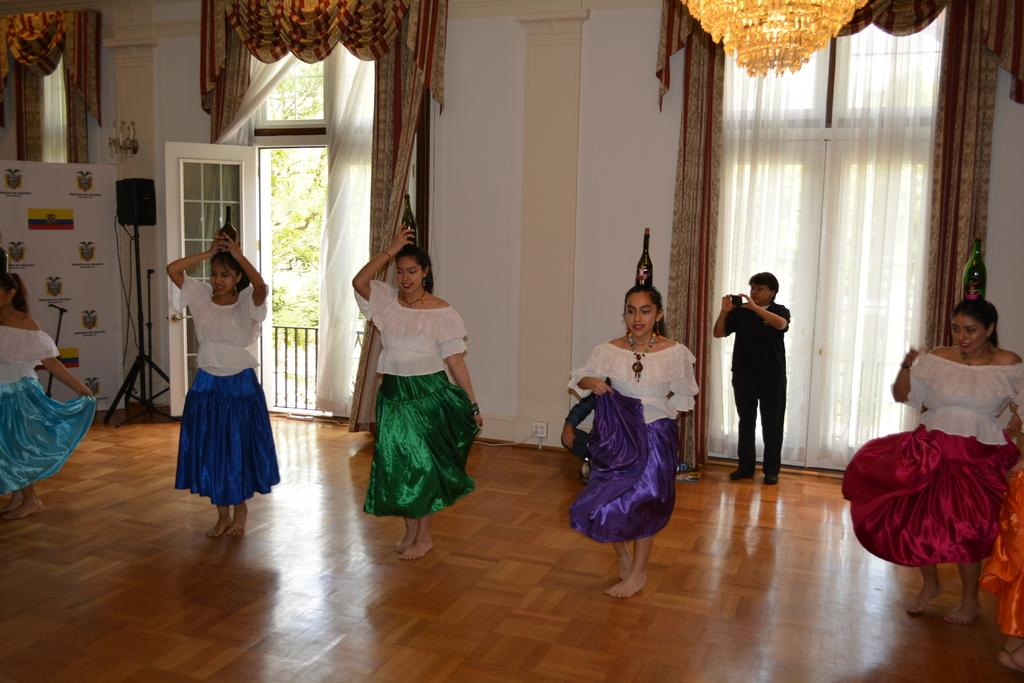What are the people in the image doing? The people in the image are dancing. What are the people wearing while dancing? The people are wearing skirts. What unusual object are the people holding while dancing? The people are holding bottles on their heads. What type of structure can be seen in the image? There is a wall in the image. Can you describe the door in the image? There is a door with curtains in the image. How does the heat affect the people's dancing in the image? There is no mention of heat in the image, so we cannot determine its effect on the people's dancing. Can you tell me if the people are driving any vehicles in the image? There are no vehicles present in the image, so the people are not driving. 